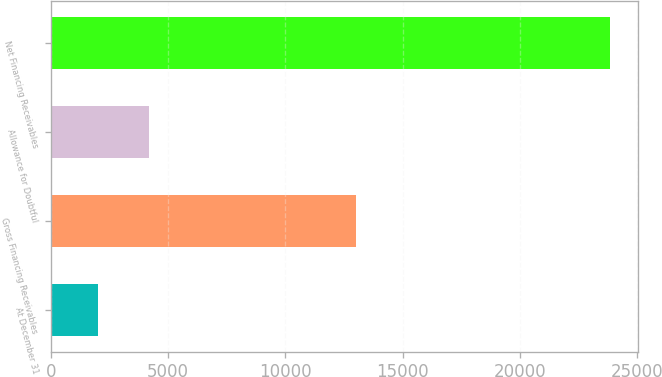Convert chart to OTSL. <chart><loc_0><loc_0><loc_500><loc_500><bar_chart><fcel>At December 31<fcel>Gross Financing Receivables<fcel>Allowance for Doubtful<fcel>Net Financing Receivables<nl><fcel>2013<fcel>13031<fcel>4194.5<fcel>23828<nl></chart> 